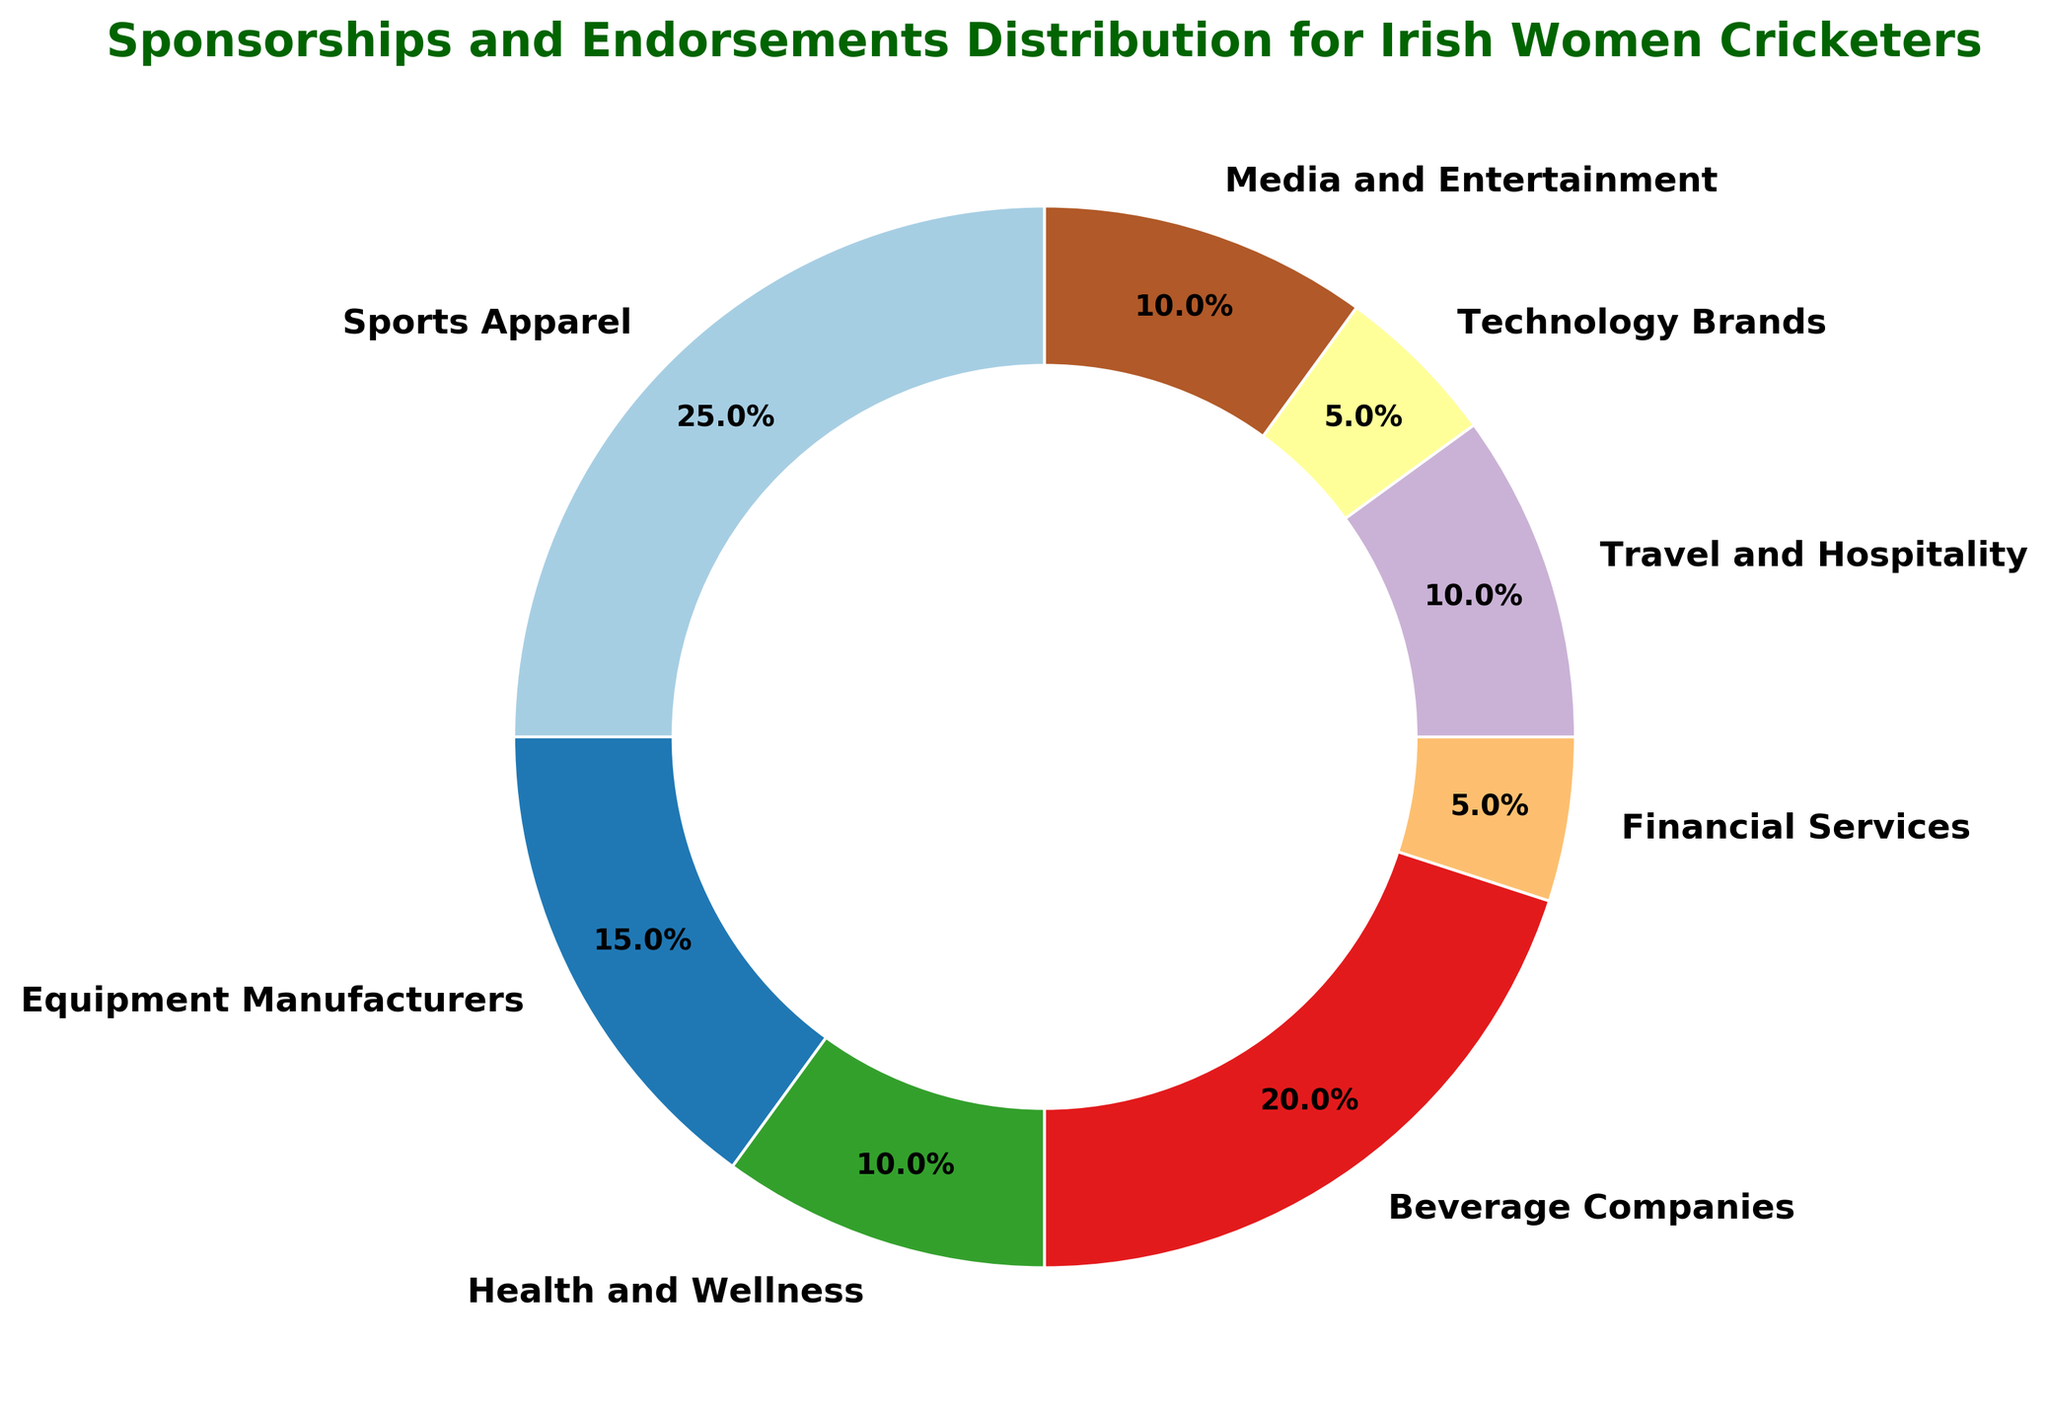What percentage of the sponsorships and endorsements are from Health and Wellness and Beverage Companies combined? To find the combined percentage, add the percentage values of Health and Wellness (10%) and Beverage Companies (20%). Thus, 10% + 20% = 30%.
Answer: 30% Which category has the highest percentage of sponsorships and endorsements? By visually inspecting the chart, the category with the largest segment is Sports Apparel with 25%.
Answer: Sports Apparel Are the percentages of sponsorships from Technology Brands and Financial Services combined greater or less than those from Beverage Companies? Add the percentages of Technology Brands (5%) and Financial Services (5%) to get their combined total: 5% + 5% = 10%. Compare this to Beverage Companies, which have 20%. 10% is less than 20%.
Answer: Less How many categories have exactly 10% sponsorships and endorsements? By looking at the chart, there are three categories: Health and Wellness, Travel and Hospitality, and Media and Entertainment, each with 10%.
Answer: Three What is the difference between the percentages of sponsorships from Travel and Hospitality and Financial Services? Subtract the percentage of Financial Services (5%) from Travel and Hospitality (10%). Therefore, 10% - 5% = 5%.
Answer: 5% Which category occupies the smallest section of the ring chart? By inspecting the sizes of segments, the smallest section belongs to Financial Services with 5%.
Answer: Financial Services How does the percentage of Equipment Manufacturers compare to that of Media and Entertainment? Both categories have the same percentage of 10%, so Equipment Manufacturers (15%) has more percentage than Media and Entertainment (10%)
Answer: Equipment Manufacturers has more Is the combined percentage of the non-traditional sponsors (Technology Brands, Financial Services, Media and Entertainment) greater than that of Sports Apparel? Add the percentages: Technology Brands (5%), Financial Services (5%), Media and Entertainment (10%), so 5% + 5% + 10% = 20%. Compare with Sports Apparel (25%). Yes, 20% is less than 25%.
Answer: No 